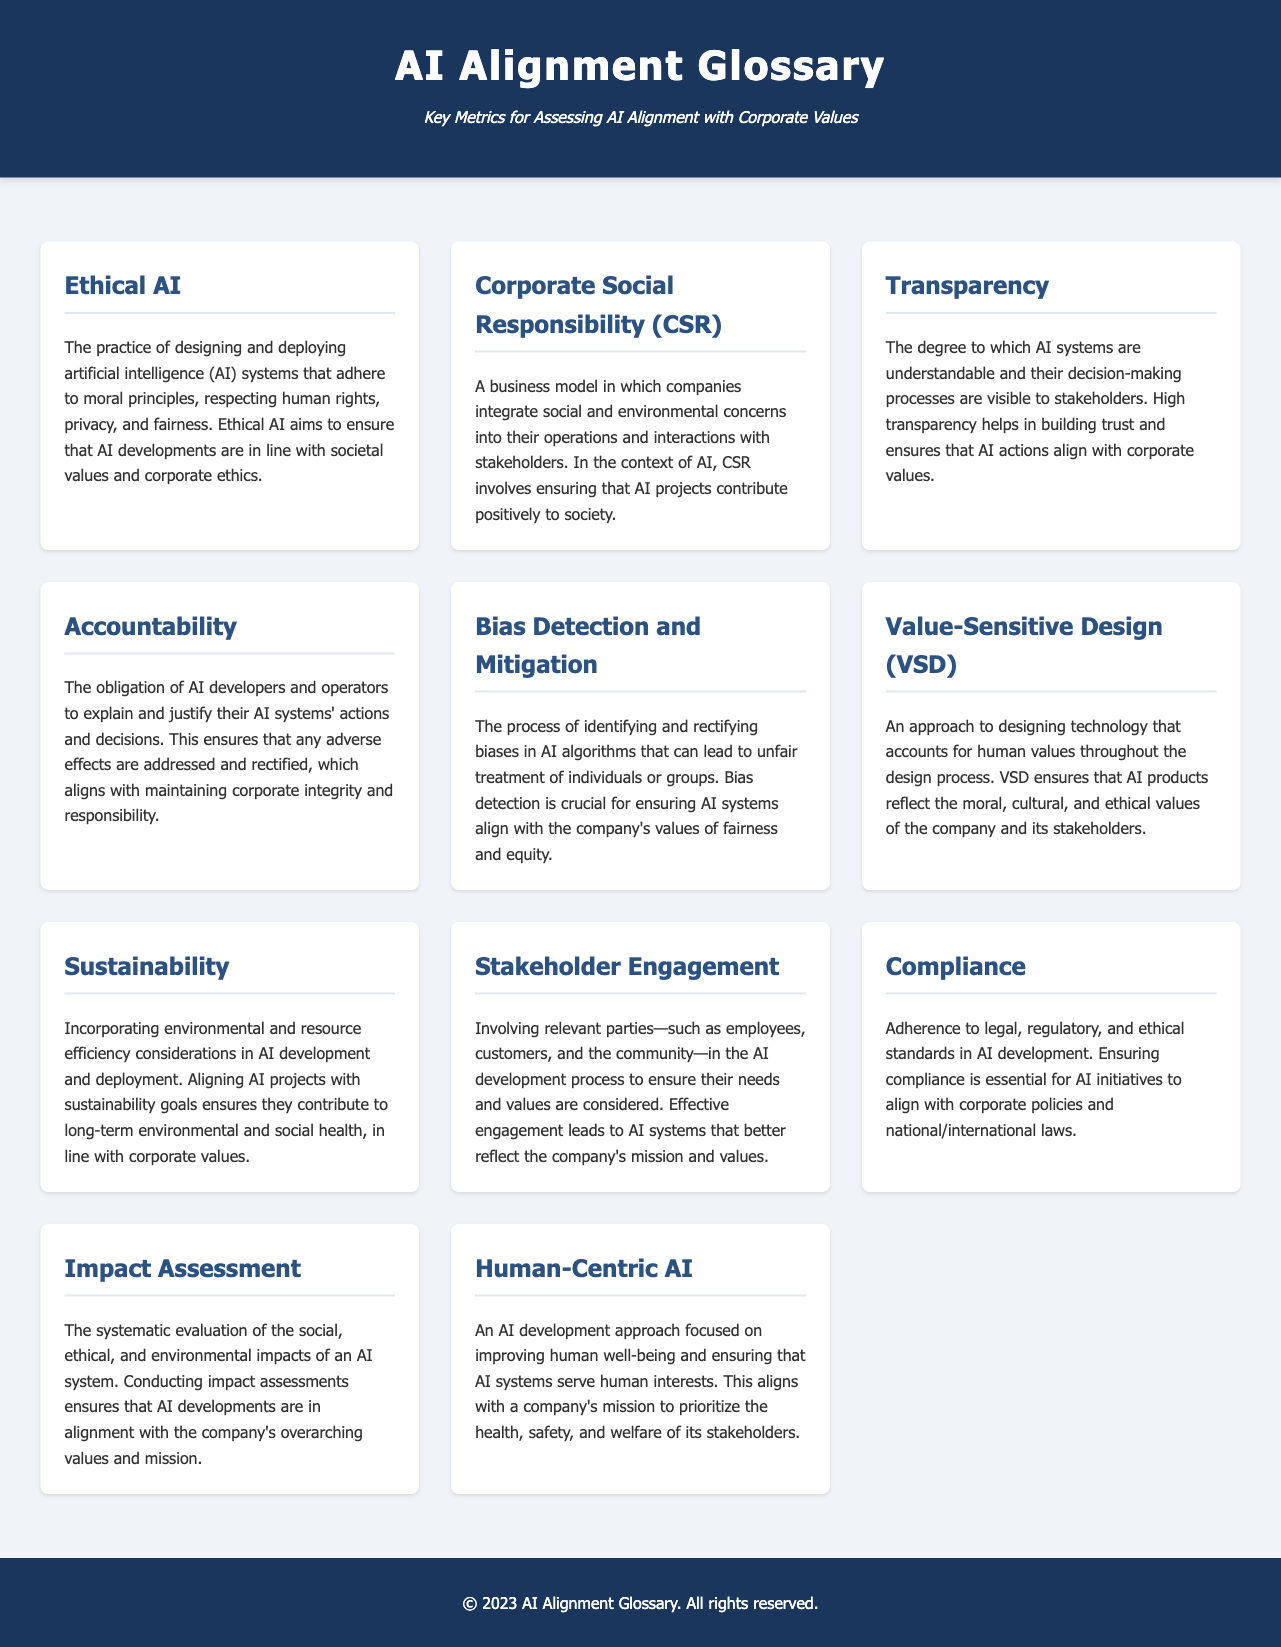What is Ethical AI? Ethical AI refers to the practice of designing and deploying artificial intelligence systems that adhere to moral principles, respecting human rights, privacy, and fairness.
Answer: The practice of designing and deploying artificial intelligence systems that adhere to moral principles, respecting human rights, privacy, and fairness What does CSR stand for? CSR stands for Corporate Social Responsibility, which integrates social and environmental concerns into business operations.
Answer: Corporate Social Responsibility What is the role of Transparency in AI? Transparency is the degree to which AI systems are understandable and their decision-making processes are visible to stakeholders.
Answer: Understandable AI systems and visible decision-making processes What is the focus of Human-Centric AI? Human-Centric AI focuses on improving human well-being and ensuring that AI systems serve human interests.
Answer: Improving human well-being What is the main goal of Value-Sensitive Design? Value-Sensitive Design aims to account for human values throughout the design process.
Answer: To account for human values throughout the design process What does Impact Assessment evaluate? Impact Assessment evaluates the social, ethical, and environmental impacts of an AI system.
Answer: Social, ethical, and environmental impacts What does the term Bias Detection and Mitigation refer to? Bias Detection and Mitigation refers to the process of identifying and rectifying biases in AI algorithms.
Answer: Identifying and rectifying biases in AI algorithms What is essential for AI initiatives to align with corporate policies? Essential for this alignment is Compliance with legal, regulatory, and ethical standards in AI development.
Answer: Compliance What involves involving relevant parties in AI development? Stakeholder Engagement involves employees, customers, and the community in the AI development process.
Answer: Involving relevant parties What is Sustainability in the context of AI? Sustainability in AI incorporates environmental and resource efficiency considerations in development and deployment.
Answer: Incorporating environmental and resource efficiency considerations 